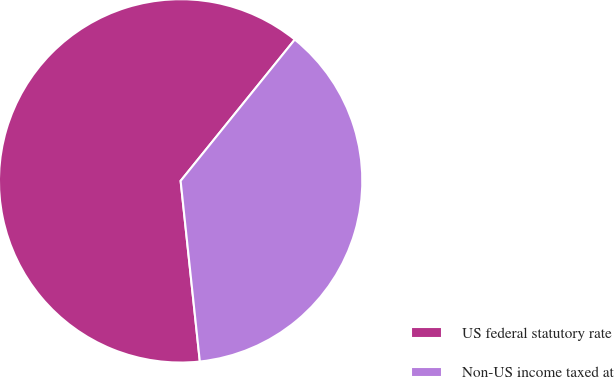Convert chart to OTSL. <chart><loc_0><loc_0><loc_500><loc_500><pie_chart><fcel>US federal statutory rate<fcel>Non-US income taxed at<nl><fcel>62.5%<fcel>37.5%<nl></chart> 